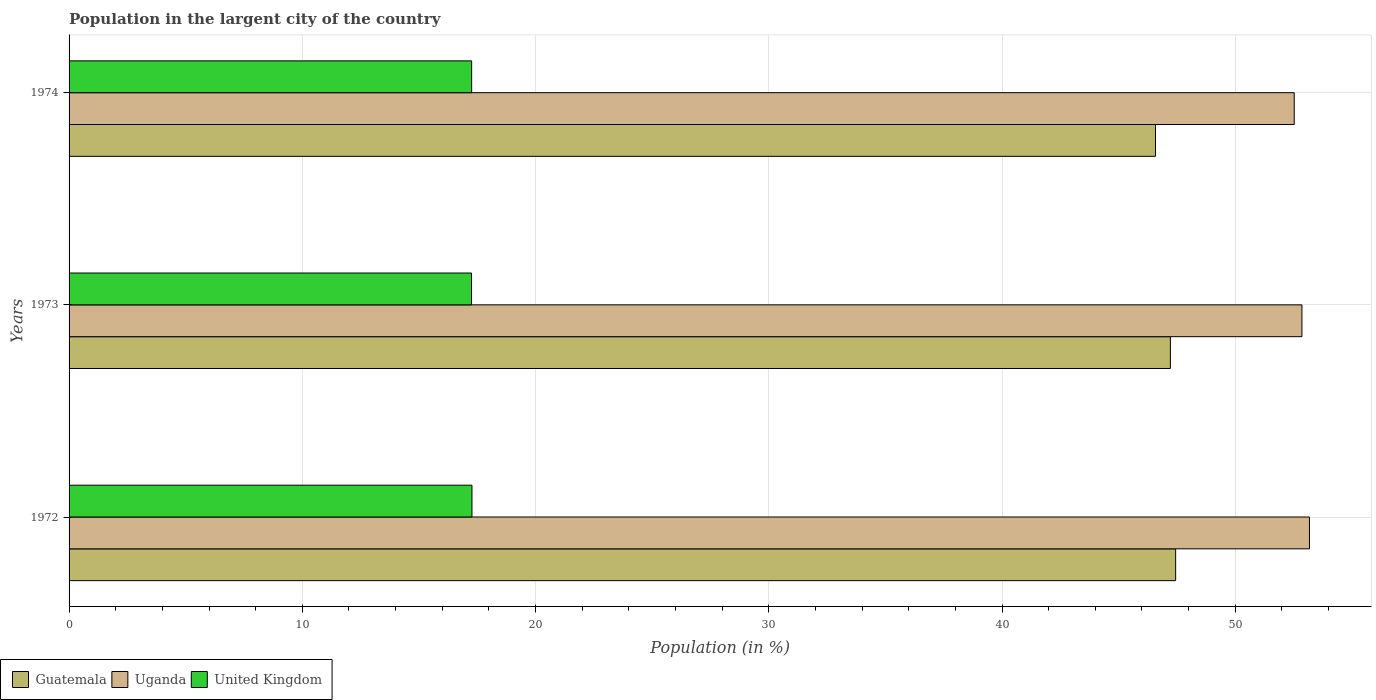How many bars are there on the 2nd tick from the top?
Your answer should be compact. 3. What is the percentage of population in the largent city in Uganda in 1974?
Provide a short and direct response. 52.53. Across all years, what is the maximum percentage of population in the largent city in Guatemala?
Keep it short and to the point. 47.45. Across all years, what is the minimum percentage of population in the largent city in United Kingdom?
Provide a short and direct response. 17.26. In which year was the percentage of population in the largent city in United Kingdom maximum?
Make the answer very short. 1972. In which year was the percentage of population in the largent city in Guatemala minimum?
Offer a very short reply. 1974. What is the total percentage of population in the largent city in United Kingdom in the graph?
Offer a terse response. 51.79. What is the difference between the percentage of population in the largent city in Guatemala in 1972 and that in 1973?
Offer a very short reply. 0.23. What is the difference between the percentage of population in the largent city in Uganda in 1973 and the percentage of population in the largent city in Guatemala in 1972?
Your response must be concise. 5.41. What is the average percentage of population in the largent city in Guatemala per year?
Your answer should be compact. 47.08. In the year 1972, what is the difference between the percentage of population in the largent city in Uganda and percentage of population in the largent city in United Kingdom?
Your response must be concise. 35.91. What is the ratio of the percentage of population in the largent city in Guatemala in 1972 to that in 1973?
Keep it short and to the point. 1. What is the difference between the highest and the second highest percentage of population in the largent city in Guatemala?
Provide a succinct answer. 0.23. What is the difference between the highest and the lowest percentage of population in the largent city in United Kingdom?
Give a very brief answer. 0.02. What does the 2nd bar from the top in 1972 represents?
Provide a short and direct response. Uganda. Is it the case that in every year, the sum of the percentage of population in the largent city in United Kingdom and percentage of population in the largent city in Guatemala is greater than the percentage of population in the largent city in Uganda?
Keep it short and to the point. Yes. How many years are there in the graph?
Your response must be concise. 3. Are the values on the major ticks of X-axis written in scientific E-notation?
Provide a short and direct response. No. Does the graph contain grids?
Ensure brevity in your answer.  Yes. What is the title of the graph?
Give a very brief answer. Population in the largent city of the country. What is the Population (in %) in Guatemala in 1972?
Make the answer very short. 47.45. What is the Population (in %) of Uganda in 1972?
Provide a short and direct response. 53.18. What is the Population (in %) in United Kingdom in 1972?
Offer a terse response. 17.27. What is the Population (in %) of Guatemala in 1973?
Ensure brevity in your answer.  47.22. What is the Population (in %) of Uganda in 1973?
Provide a short and direct response. 52.86. What is the Population (in %) in United Kingdom in 1973?
Your answer should be compact. 17.26. What is the Population (in %) in Guatemala in 1974?
Provide a short and direct response. 46.58. What is the Population (in %) of Uganda in 1974?
Provide a short and direct response. 52.53. What is the Population (in %) of United Kingdom in 1974?
Keep it short and to the point. 17.26. Across all years, what is the maximum Population (in %) in Guatemala?
Your answer should be compact. 47.45. Across all years, what is the maximum Population (in %) in Uganda?
Your answer should be very brief. 53.18. Across all years, what is the maximum Population (in %) of United Kingdom?
Keep it short and to the point. 17.27. Across all years, what is the minimum Population (in %) of Guatemala?
Provide a succinct answer. 46.58. Across all years, what is the minimum Population (in %) of Uganda?
Give a very brief answer. 52.53. Across all years, what is the minimum Population (in %) of United Kingdom?
Ensure brevity in your answer.  17.26. What is the total Population (in %) in Guatemala in the graph?
Offer a terse response. 141.25. What is the total Population (in %) in Uganda in the graph?
Offer a terse response. 158.57. What is the total Population (in %) of United Kingdom in the graph?
Ensure brevity in your answer.  51.79. What is the difference between the Population (in %) of Guatemala in 1972 and that in 1973?
Ensure brevity in your answer.  0.23. What is the difference between the Population (in %) of Uganda in 1972 and that in 1973?
Ensure brevity in your answer.  0.32. What is the difference between the Population (in %) in United Kingdom in 1972 and that in 1973?
Your response must be concise. 0.02. What is the difference between the Population (in %) of Guatemala in 1972 and that in 1974?
Offer a terse response. 0.86. What is the difference between the Population (in %) in Uganda in 1972 and that in 1974?
Make the answer very short. 0.65. What is the difference between the Population (in %) in United Kingdom in 1972 and that in 1974?
Ensure brevity in your answer.  0.01. What is the difference between the Population (in %) of Guatemala in 1973 and that in 1974?
Your answer should be very brief. 0.64. What is the difference between the Population (in %) in Uganda in 1973 and that in 1974?
Your answer should be very brief. 0.33. What is the difference between the Population (in %) in United Kingdom in 1973 and that in 1974?
Your answer should be very brief. -0. What is the difference between the Population (in %) in Guatemala in 1972 and the Population (in %) in Uganda in 1973?
Give a very brief answer. -5.41. What is the difference between the Population (in %) in Guatemala in 1972 and the Population (in %) in United Kingdom in 1973?
Your response must be concise. 30.19. What is the difference between the Population (in %) in Uganda in 1972 and the Population (in %) in United Kingdom in 1973?
Your response must be concise. 35.93. What is the difference between the Population (in %) of Guatemala in 1972 and the Population (in %) of Uganda in 1974?
Offer a very short reply. -5.08. What is the difference between the Population (in %) of Guatemala in 1972 and the Population (in %) of United Kingdom in 1974?
Provide a succinct answer. 30.18. What is the difference between the Population (in %) of Uganda in 1972 and the Population (in %) of United Kingdom in 1974?
Offer a very short reply. 35.92. What is the difference between the Population (in %) of Guatemala in 1973 and the Population (in %) of Uganda in 1974?
Your answer should be very brief. -5.31. What is the difference between the Population (in %) in Guatemala in 1973 and the Population (in %) in United Kingdom in 1974?
Your response must be concise. 29.96. What is the difference between the Population (in %) of Uganda in 1973 and the Population (in %) of United Kingdom in 1974?
Ensure brevity in your answer.  35.6. What is the average Population (in %) in Guatemala per year?
Provide a short and direct response. 47.08. What is the average Population (in %) of Uganda per year?
Provide a succinct answer. 52.86. What is the average Population (in %) of United Kingdom per year?
Offer a terse response. 17.26. In the year 1972, what is the difference between the Population (in %) in Guatemala and Population (in %) in Uganda?
Provide a succinct answer. -5.74. In the year 1972, what is the difference between the Population (in %) of Guatemala and Population (in %) of United Kingdom?
Keep it short and to the point. 30.17. In the year 1972, what is the difference between the Population (in %) of Uganda and Population (in %) of United Kingdom?
Keep it short and to the point. 35.91. In the year 1973, what is the difference between the Population (in %) of Guatemala and Population (in %) of Uganda?
Your answer should be very brief. -5.64. In the year 1973, what is the difference between the Population (in %) in Guatemala and Population (in %) in United Kingdom?
Your response must be concise. 29.96. In the year 1973, what is the difference between the Population (in %) in Uganda and Population (in %) in United Kingdom?
Offer a terse response. 35.6. In the year 1974, what is the difference between the Population (in %) of Guatemala and Population (in %) of Uganda?
Provide a short and direct response. -5.95. In the year 1974, what is the difference between the Population (in %) in Guatemala and Population (in %) in United Kingdom?
Your response must be concise. 29.32. In the year 1974, what is the difference between the Population (in %) of Uganda and Population (in %) of United Kingdom?
Offer a terse response. 35.27. What is the ratio of the Population (in %) in Guatemala in 1972 to that in 1973?
Your answer should be very brief. 1. What is the ratio of the Population (in %) of United Kingdom in 1972 to that in 1973?
Provide a succinct answer. 1. What is the ratio of the Population (in %) in Guatemala in 1972 to that in 1974?
Offer a very short reply. 1.02. What is the ratio of the Population (in %) of Uganda in 1972 to that in 1974?
Offer a terse response. 1.01. What is the ratio of the Population (in %) of Guatemala in 1973 to that in 1974?
Your answer should be compact. 1.01. What is the ratio of the Population (in %) in Uganda in 1973 to that in 1974?
Your answer should be very brief. 1.01. What is the ratio of the Population (in %) of United Kingdom in 1973 to that in 1974?
Provide a short and direct response. 1. What is the difference between the highest and the second highest Population (in %) in Guatemala?
Ensure brevity in your answer.  0.23. What is the difference between the highest and the second highest Population (in %) in Uganda?
Offer a terse response. 0.32. What is the difference between the highest and the second highest Population (in %) of United Kingdom?
Provide a succinct answer. 0.01. What is the difference between the highest and the lowest Population (in %) of Guatemala?
Provide a short and direct response. 0.86. What is the difference between the highest and the lowest Population (in %) in Uganda?
Make the answer very short. 0.65. What is the difference between the highest and the lowest Population (in %) in United Kingdom?
Offer a very short reply. 0.02. 